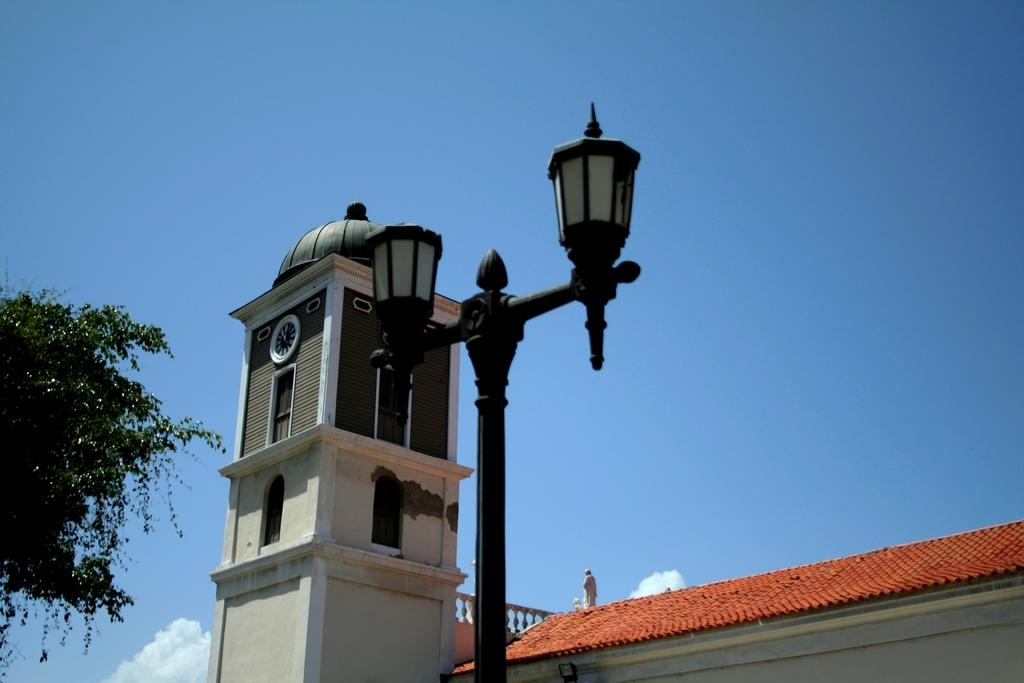What is hanging on the pole in the image? There are lanterns or lamps on a pole in the image. What can be seen in the background of the image? In the background, there is a clock tower, a statue, a roof, a tree, and the sky is blue. What features does the clock tower have? The clock tower has windows and a clock. How many rabbits are hopping around the tree in the image? There are no rabbits present in the image; it features a tree in the background. What type of chain is holding the clock tower in the image? There is no chain visible in the image; the clock tower is standing on its own. 